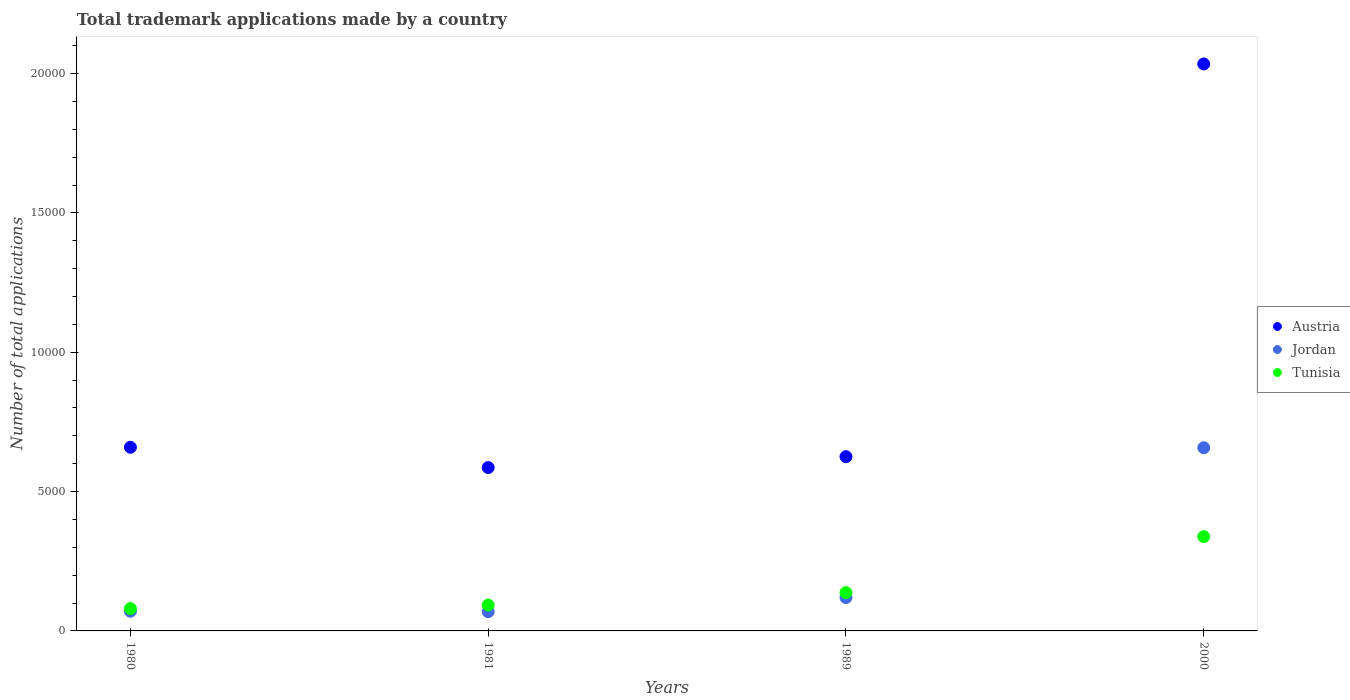Is the number of dotlines equal to the number of legend labels?
Provide a short and direct response. Yes. What is the number of applications made by in Tunisia in 2000?
Ensure brevity in your answer.  3384. Across all years, what is the maximum number of applications made by in Tunisia?
Your answer should be compact. 3384. Across all years, what is the minimum number of applications made by in Tunisia?
Your answer should be very brief. 801. In which year was the number of applications made by in Jordan minimum?
Your answer should be very brief. 1981. What is the total number of applications made by in Jordan in the graph?
Offer a very short reply. 9168. What is the difference between the number of applications made by in Austria in 1981 and that in 2000?
Your answer should be very brief. -1.45e+04. What is the difference between the number of applications made by in Austria in 1989 and the number of applications made by in Tunisia in 1980?
Ensure brevity in your answer.  5452. What is the average number of applications made by in Austria per year?
Your answer should be very brief. 9762.25. In the year 1981, what is the difference between the number of applications made by in Austria and number of applications made by in Tunisia?
Keep it short and to the point. 4934. In how many years, is the number of applications made by in Austria greater than 17000?
Offer a terse response. 1. What is the ratio of the number of applications made by in Jordan in 1980 to that in 1989?
Keep it short and to the point. 0.59. Is the number of applications made by in Austria in 1989 less than that in 2000?
Keep it short and to the point. Yes. What is the difference between the highest and the second highest number of applications made by in Austria?
Provide a succinct answer. 1.38e+04. What is the difference between the highest and the lowest number of applications made by in Jordan?
Keep it short and to the point. 5882. In how many years, is the number of applications made by in Tunisia greater than the average number of applications made by in Tunisia taken over all years?
Ensure brevity in your answer.  1. Is it the case that in every year, the sum of the number of applications made by in Tunisia and number of applications made by in Austria  is greater than the number of applications made by in Jordan?
Provide a short and direct response. Yes. Does the number of applications made by in Austria monotonically increase over the years?
Offer a terse response. No. Is the number of applications made by in Austria strictly less than the number of applications made by in Tunisia over the years?
Make the answer very short. No. How many years are there in the graph?
Your answer should be compact. 4. What is the difference between two consecutive major ticks on the Y-axis?
Make the answer very short. 5000. How are the legend labels stacked?
Provide a short and direct response. Vertical. What is the title of the graph?
Offer a terse response. Total trademark applications made by a country. What is the label or title of the X-axis?
Offer a terse response. Years. What is the label or title of the Y-axis?
Give a very brief answer. Number of total applications. What is the Number of total applications of Austria in 1980?
Provide a short and direct response. 6590. What is the Number of total applications of Jordan in 1980?
Your answer should be compact. 707. What is the Number of total applications in Tunisia in 1980?
Offer a terse response. 801. What is the Number of total applications of Austria in 1981?
Keep it short and to the point. 5862. What is the Number of total applications in Jordan in 1981?
Offer a very short reply. 691. What is the Number of total applications of Tunisia in 1981?
Keep it short and to the point. 928. What is the Number of total applications of Austria in 1989?
Keep it short and to the point. 6253. What is the Number of total applications in Jordan in 1989?
Provide a short and direct response. 1197. What is the Number of total applications in Tunisia in 1989?
Your answer should be compact. 1374. What is the Number of total applications in Austria in 2000?
Make the answer very short. 2.03e+04. What is the Number of total applications in Jordan in 2000?
Provide a short and direct response. 6573. What is the Number of total applications in Tunisia in 2000?
Your answer should be compact. 3384. Across all years, what is the maximum Number of total applications of Austria?
Make the answer very short. 2.03e+04. Across all years, what is the maximum Number of total applications in Jordan?
Provide a succinct answer. 6573. Across all years, what is the maximum Number of total applications in Tunisia?
Your answer should be compact. 3384. Across all years, what is the minimum Number of total applications of Austria?
Your response must be concise. 5862. Across all years, what is the minimum Number of total applications of Jordan?
Offer a very short reply. 691. Across all years, what is the minimum Number of total applications in Tunisia?
Offer a very short reply. 801. What is the total Number of total applications in Austria in the graph?
Keep it short and to the point. 3.90e+04. What is the total Number of total applications of Jordan in the graph?
Your answer should be very brief. 9168. What is the total Number of total applications of Tunisia in the graph?
Give a very brief answer. 6487. What is the difference between the Number of total applications in Austria in 1980 and that in 1981?
Provide a short and direct response. 728. What is the difference between the Number of total applications of Tunisia in 1980 and that in 1981?
Ensure brevity in your answer.  -127. What is the difference between the Number of total applications of Austria in 1980 and that in 1989?
Make the answer very short. 337. What is the difference between the Number of total applications in Jordan in 1980 and that in 1989?
Keep it short and to the point. -490. What is the difference between the Number of total applications in Tunisia in 1980 and that in 1989?
Provide a short and direct response. -573. What is the difference between the Number of total applications of Austria in 1980 and that in 2000?
Ensure brevity in your answer.  -1.38e+04. What is the difference between the Number of total applications in Jordan in 1980 and that in 2000?
Give a very brief answer. -5866. What is the difference between the Number of total applications of Tunisia in 1980 and that in 2000?
Ensure brevity in your answer.  -2583. What is the difference between the Number of total applications of Austria in 1981 and that in 1989?
Ensure brevity in your answer.  -391. What is the difference between the Number of total applications of Jordan in 1981 and that in 1989?
Provide a succinct answer. -506. What is the difference between the Number of total applications of Tunisia in 1981 and that in 1989?
Ensure brevity in your answer.  -446. What is the difference between the Number of total applications of Austria in 1981 and that in 2000?
Offer a very short reply. -1.45e+04. What is the difference between the Number of total applications of Jordan in 1981 and that in 2000?
Provide a succinct answer. -5882. What is the difference between the Number of total applications in Tunisia in 1981 and that in 2000?
Your answer should be very brief. -2456. What is the difference between the Number of total applications in Austria in 1989 and that in 2000?
Keep it short and to the point. -1.41e+04. What is the difference between the Number of total applications of Jordan in 1989 and that in 2000?
Offer a terse response. -5376. What is the difference between the Number of total applications in Tunisia in 1989 and that in 2000?
Ensure brevity in your answer.  -2010. What is the difference between the Number of total applications of Austria in 1980 and the Number of total applications of Jordan in 1981?
Make the answer very short. 5899. What is the difference between the Number of total applications of Austria in 1980 and the Number of total applications of Tunisia in 1981?
Offer a terse response. 5662. What is the difference between the Number of total applications of Jordan in 1980 and the Number of total applications of Tunisia in 1981?
Provide a short and direct response. -221. What is the difference between the Number of total applications in Austria in 1980 and the Number of total applications in Jordan in 1989?
Keep it short and to the point. 5393. What is the difference between the Number of total applications in Austria in 1980 and the Number of total applications in Tunisia in 1989?
Your answer should be very brief. 5216. What is the difference between the Number of total applications in Jordan in 1980 and the Number of total applications in Tunisia in 1989?
Provide a succinct answer. -667. What is the difference between the Number of total applications in Austria in 1980 and the Number of total applications in Tunisia in 2000?
Provide a short and direct response. 3206. What is the difference between the Number of total applications in Jordan in 1980 and the Number of total applications in Tunisia in 2000?
Keep it short and to the point. -2677. What is the difference between the Number of total applications of Austria in 1981 and the Number of total applications of Jordan in 1989?
Your response must be concise. 4665. What is the difference between the Number of total applications of Austria in 1981 and the Number of total applications of Tunisia in 1989?
Give a very brief answer. 4488. What is the difference between the Number of total applications of Jordan in 1981 and the Number of total applications of Tunisia in 1989?
Make the answer very short. -683. What is the difference between the Number of total applications in Austria in 1981 and the Number of total applications in Jordan in 2000?
Ensure brevity in your answer.  -711. What is the difference between the Number of total applications of Austria in 1981 and the Number of total applications of Tunisia in 2000?
Offer a terse response. 2478. What is the difference between the Number of total applications of Jordan in 1981 and the Number of total applications of Tunisia in 2000?
Keep it short and to the point. -2693. What is the difference between the Number of total applications of Austria in 1989 and the Number of total applications of Jordan in 2000?
Offer a very short reply. -320. What is the difference between the Number of total applications of Austria in 1989 and the Number of total applications of Tunisia in 2000?
Your response must be concise. 2869. What is the difference between the Number of total applications in Jordan in 1989 and the Number of total applications in Tunisia in 2000?
Make the answer very short. -2187. What is the average Number of total applications in Austria per year?
Keep it short and to the point. 9762.25. What is the average Number of total applications in Jordan per year?
Keep it short and to the point. 2292. What is the average Number of total applications in Tunisia per year?
Ensure brevity in your answer.  1621.75. In the year 1980, what is the difference between the Number of total applications of Austria and Number of total applications of Jordan?
Provide a succinct answer. 5883. In the year 1980, what is the difference between the Number of total applications in Austria and Number of total applications in Tunisia?
Your answer should be very brief. 5789. In the year 1980, what is the difference between the Number of total applications of Jordan and Number of total applications of Tunisia?
Make the answer very short. -94. In the year 1981, what is the difference between the Number of total applications in Austria and Number of total applications in Jordan?
Offer a terse response. 5171. In the year 1981, what is the difference between the Number of total applications of Austria and Number of total applications of Tunisia?
Provide a succinct answer. 4934. In the year 1981, what is the difference between the Number of total applications in Jordan and Number of total applications in Tunisia?
Provide a succinct answer. -237. In the year 1989, what is the difference between the Number of total applications of Austria and Number of total applications of Jordan?
Keep it short and to the point. 5056. In the year 1989, what is the difference between the Number of total applications in Austria and Number of total applications in Tunisia?
Ensure brevity in your answer.  4879. In the year 1989, what is the difference between the Number of total applications of Jordan and Number of total applications of Tunisia?
Your response must be concise. -177. In the year 2000, what is the difference between the Number of total applications of Austria and Number of total applications of Jordan?
Give a very brief answer. 1.38e+04. In the year 2000, what is the difference between the Number of total applications in Austria and Number of total applications in Tunisia?
Your answer should be compact. 1.70e+04. In the year 2000, what is the difference between the Number of total applications in Jordan and Number of total applications in Tunisia?
Make the answer very short. 3189. What is the ratio of the Number of total applications of Austria in 1980 to that in 1981?
Provide a short and direct response. 1.12. What is the ratio of the Number of total applications of Jordan in 1980 to that in 1981?
Offer a very short reply. 1.02. What is the ratio of the Number of total applications of Tunisia in 1980 to that in 1981?
Your answer should be compact. 0.86. What is the ratio of the Number of total applications in Austria in 1980 to that in 1989?
Your response must be concise. 1.05. What is the ratio of the Number of total applications in Jordan in 1980 to that in 1989?
Offer a terse response. 0.59. What is the ratio of the Number of total applications in Tunisia in 1980 to that in 1989?
Offer a terse response. 0.58. What is the ratio of the Number of total applications of Austria in 1980 to that in 2000?
Give a very brief answer. 0.32. What is the ratio of the Number of total applications in Jordan in 1980 to that in 2000?
Offer a very short reply. 0.11. What is the ratio of the Number of total applications of Tunisia in 1980 to that in 2000?
Ensure brevity in your answer.  0.24. What is the ratio of the Number of total applications in Austria in 1981 to that in 1989?
Provide a succinct answer. 0.94. What is the ratio of the Number of total applications of Jordan in 1981 to that in 1989?
Give a very brief answer. 0.58. What is the ratio of the Number of total applications in Tunisia in 1981 to that in 1989?
Your answer should be very brief. 0.68. What is the ratio of the Number of total applications of Austria in 1981 to that in 2000?
Ensure brevity in your answer.  0.29. What is the ratio of the Number of total applications of Jordan in 1981 to that in 2000?
Your answer should be very brief. 0.11. What is the ratio of the Number of total applications of Tunisia in 1981 to that in 2000?
Make the answer very short. 0.27. What is the ratio of the Number of total applications in Austria in 1989 to that in 2000?
Your answer should be compact. 0.31. What is the ratio of the Number of total applications in Jordan in 1989 to that in 2000?
Offer a very short reply. 0.18. What is the ratio of the Number of total applications of Tunisia in 1989 to that in 2000?
Make the answer very short. 0.41. What is the difference between the highest and the second highest Number of total applications in Austria?
Make the answer very short. 1.38e+04. What is the difference between the highest and the second highest Number of total applications in Jordan?
Your answer should be very brief. 5376. What is the difference between the highest and the second highest Number of total applications in Tunisia?
Provide a succinct answer. 2010. What is the difference between the highest and the lowest Number of total applications of Austria?
Provide a short and direct response. 1.45e+04. What is the difference between the highest and the lowest Number of total applications in Jordan?
Give a very brief answer. 5882. What is the difference between the highest and the lowest Number of total applications of Tunisia?
Your response must be concise. 2583. 